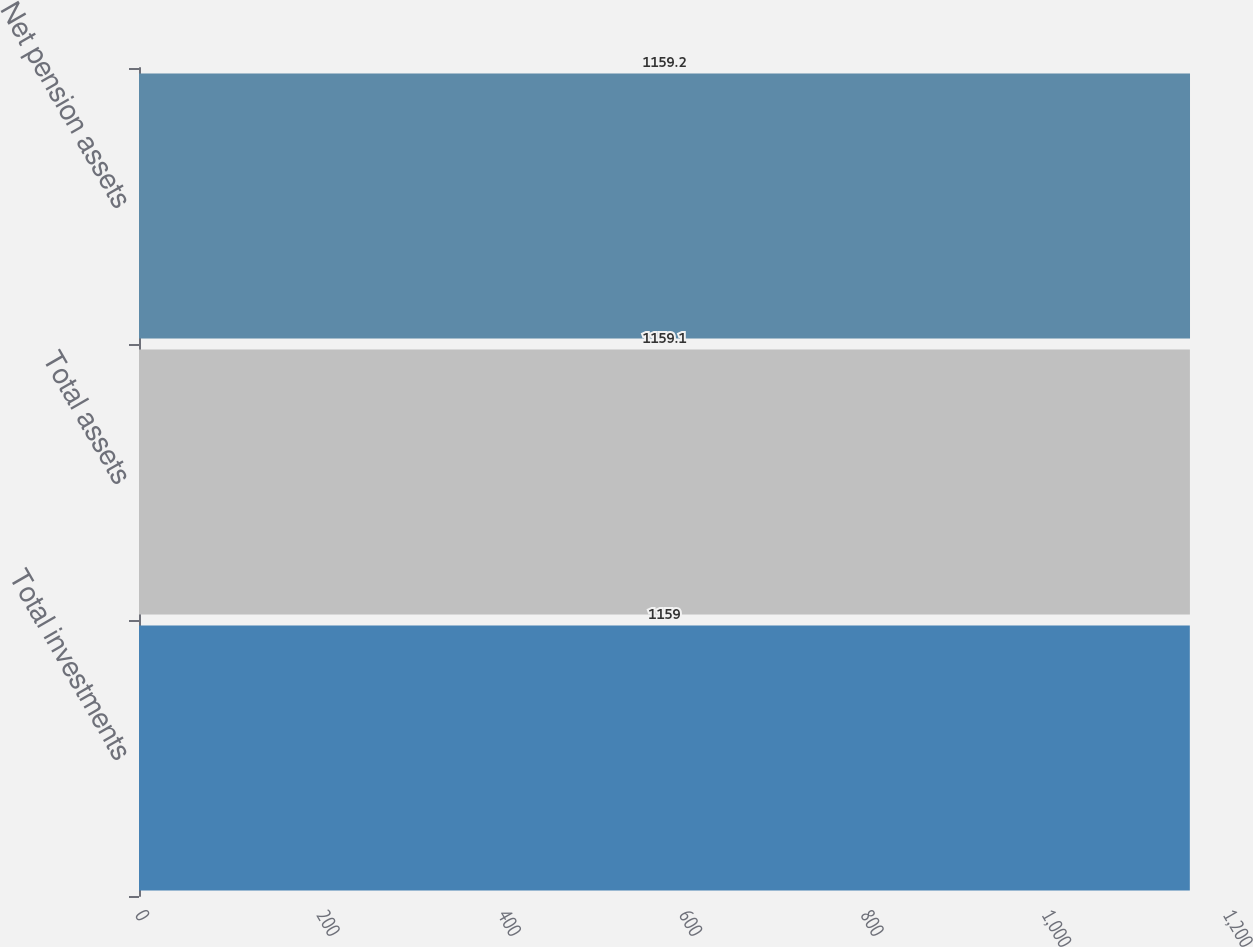Convert chart. <chart><loc_0><loc_0><loc_500><loc_500><bar_chart><fcel>Total investments<fcel>Total assets<fcel>Net pension assets<nl><fcel>1159<fcel>1159.1<fcel>1159.2<nl></chart> 